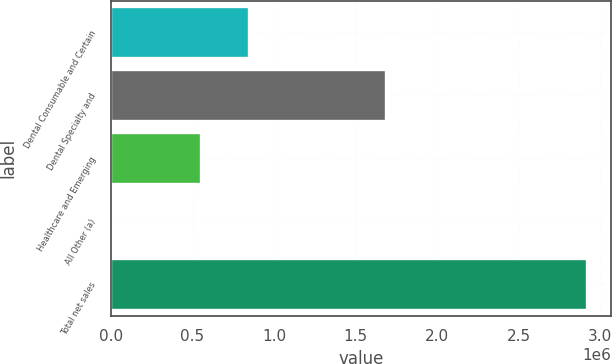Convert chart. <chart><loc_0><loc_0><loc_500><loc_500><bar_chart><fcel>Dental Consumable and Certain<fcel>Dental Specialty and<fcel>Healthcare and Emerging<fcel>All Other (a)<fcel>Total net sales<nl><fcel>843631<fcel>1.6851e+06<fcel>551775<fcel>4058<fcel>2.92262e+06<nl></chart> 